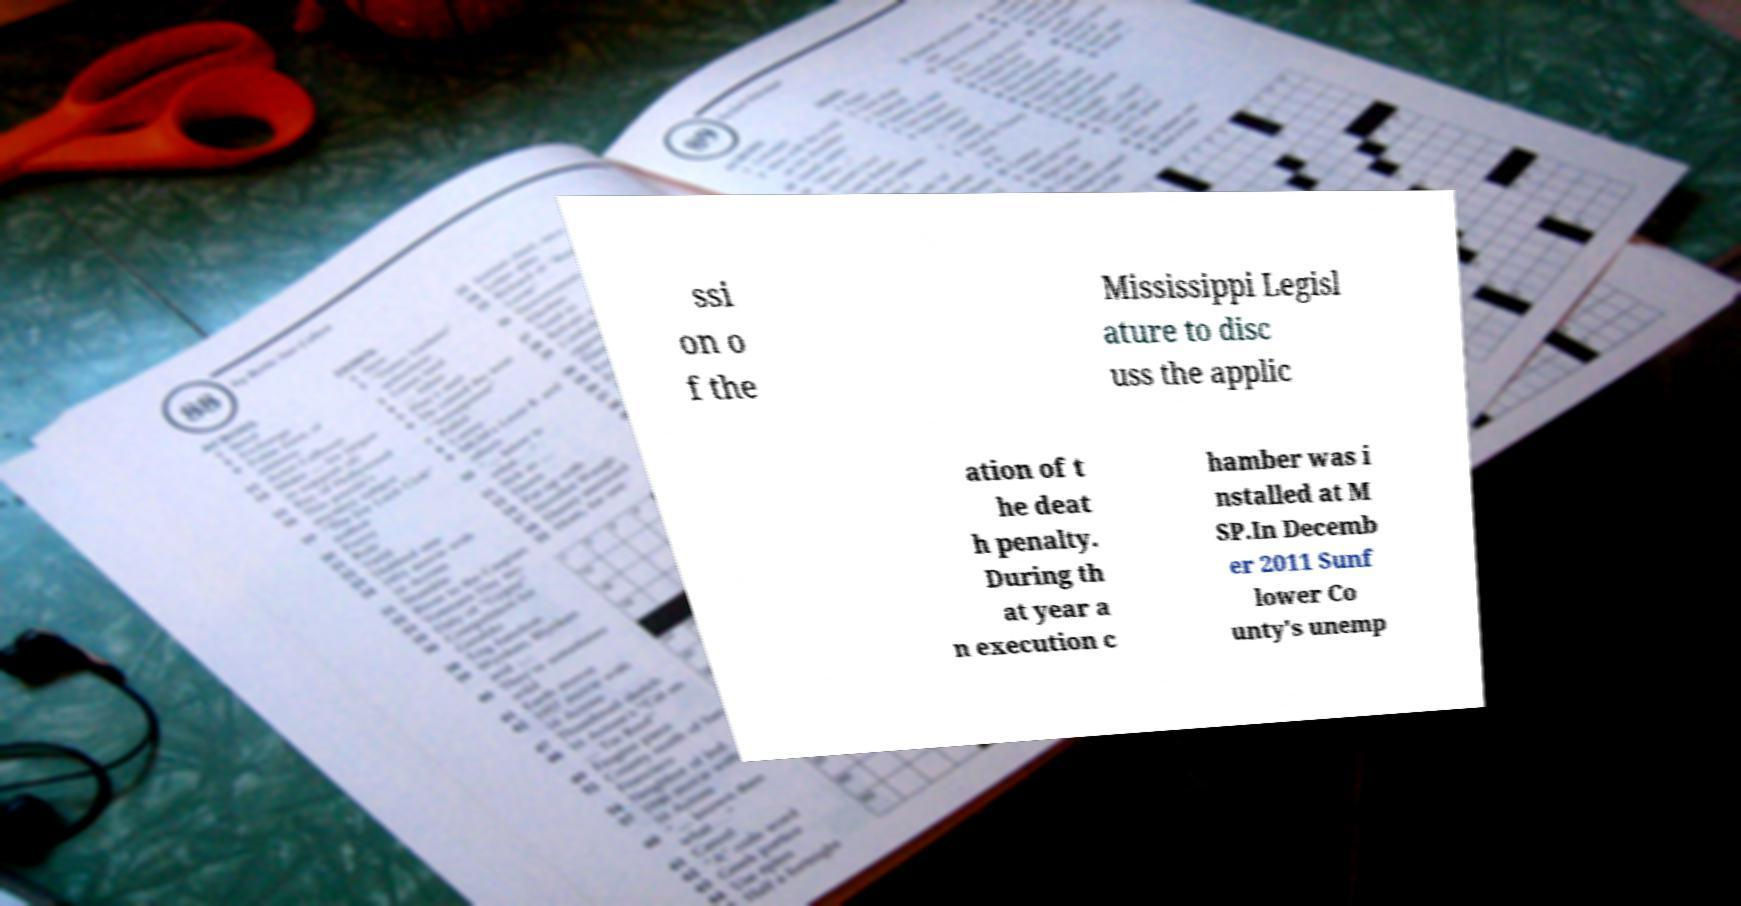What messages or text are displayed in this image? I need them in a readable, typed format. ssi on o f the Mississippi Legisl ature to disc uss the applic ation of t he deat h penalty. During th at year a n execution c hamber was i nstalled at M SP.In Decemb er 2011 Sunf lower Co unty's unemp 